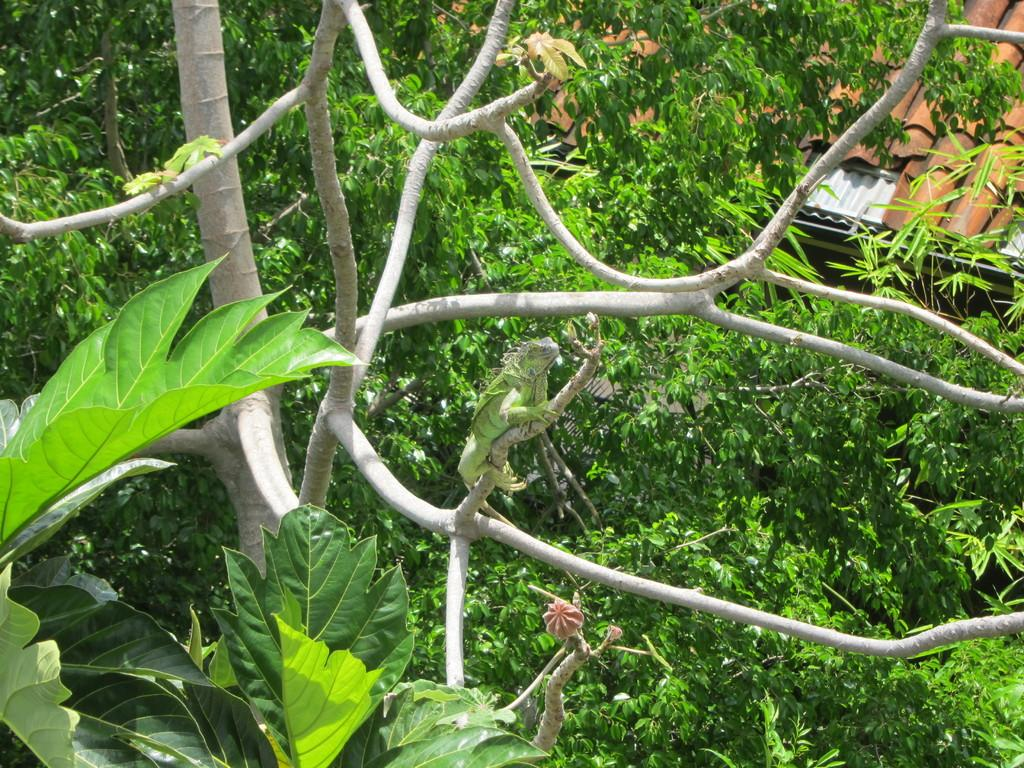What type of vegetation can be seen in the image? There are trees in the image. What is the color of the trees in the image? The trees are green in color. What type of animal is on the tree in the image? There is a reptile on the tree in the image. What is the color of the reptile in the image? The reptile is green in color. What type of structure is visible in the image? There is a building in the image. What is the color of the roof of the building in the image? The roof of the building is brown in color. What type of produce is being harvested in the image? There is no produce being harvested in the image; it features trees, a reptile, and a building. What type of liquid can be seen flowing from the reptile in the image? There is no liquid flowing from the reptile in the image; it is simply perched on the tree. 